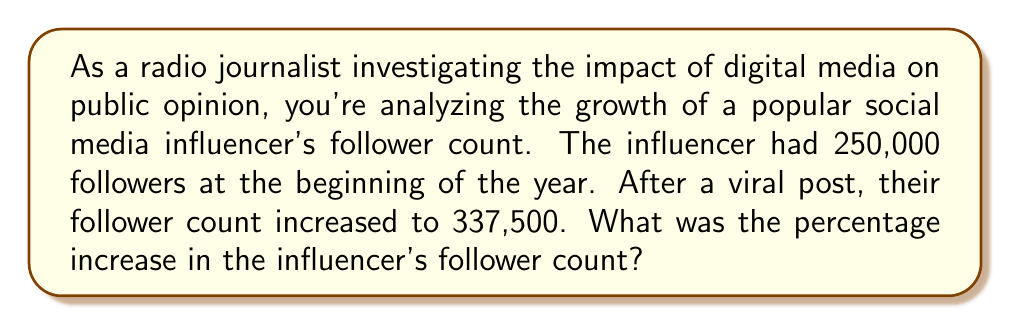Can you solve this math problem? To calculate the percentage increase, we need to follow these steps:

1. Calculate the difference between the final and initial values:
   $\text{Increase} = \text{Final value} - \text{Initial value}$
   $\text{Increase} = 337,500 - 250,000 = 87,500$

2. Divide the increase by the initial value:
   $\frac{\text{Increase}}{\text{Initial value}} = \frac{87,500}{250,000} = 0.35$

3. Convert the decimal to a percentage by multiplying by 100:
   $\text{Percentage increase} = 0.35 \times 100 = 35\%$

The formula for percentage increase can be expressed as:

$$\text{Percentage increase} = \frac{\text{Final value} - \text{Initial value}}{\text{Initial value}} \times 100\%$$

Plugging in our values:

$$\text{Percentage increase} = \frac{337,500 - 250,000}{250,000} \times 100\% = \frac{87,500}{250,000} \times 100\% = 35\%$$
Answer: The percentage increase in the influencer's follower count was 35%. 